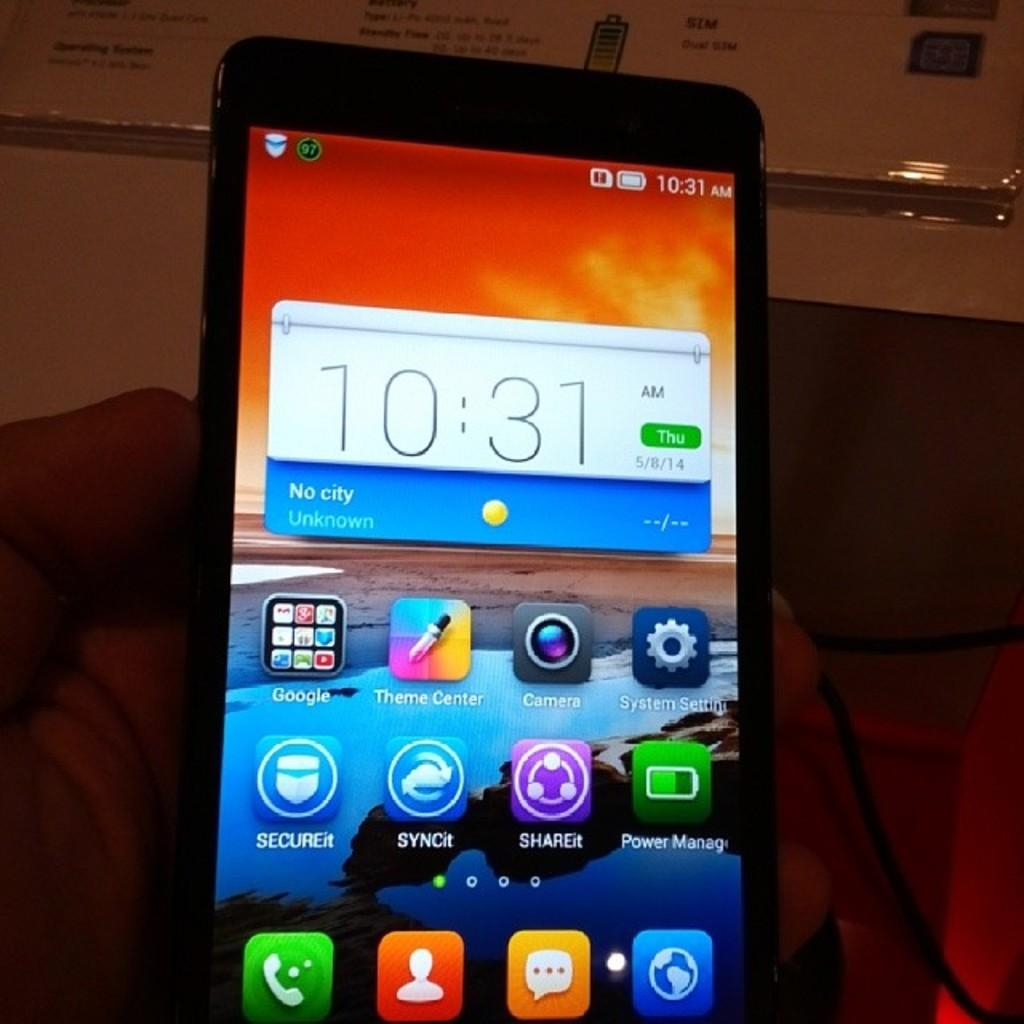<image>
Give a short and clear explanation of the subsequent image. A smartphone gives the time as 10:31am on a Thursday. 